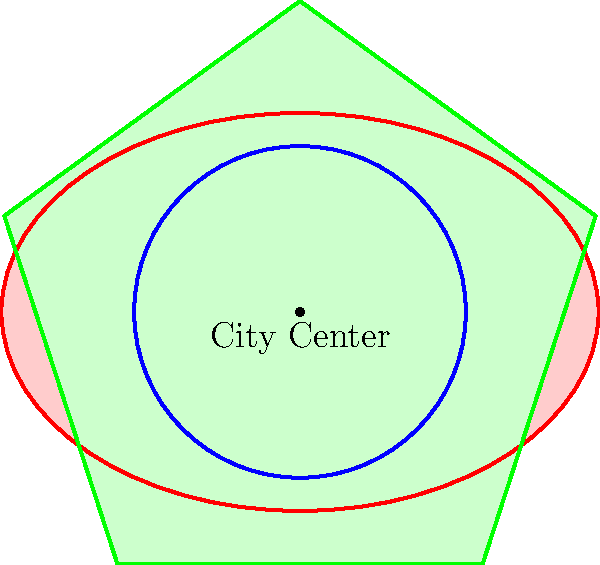Based on the map showing the changing boundaries of Manchester throughout history, which period saw the most significant expansion of the city's borders, and what historical event might have contributed to this growth? To answer this question, let's analyze the map step-by-step:

1. The map shows three distinct periods in Manchester's history, represented by different shapes and colors:
   - Blue circle: Medieval Manchester
   - Red ellipse: Industrial Revolution Manchester
   - Green pentagon: Modern Greater Manchester

2. Comparing the sizes of these shapes:
   - The blue circle (Medieval Manchester) is the smallest.
   - The red ellipse (Industrial Revolution Manchester) is noticeably larger than the medieval boundaries.
   - The green pentagon (Modern Greater Manchester) is significantly larger than both previous periods.

3. The most significant expansion is clearly between the Industrial Revolution period and the Modern Greater Manchester period.

4. Historical context:
   - The Industrial Revolution (late 18th to 19th century) brought rapid growth to Manchester due to textile manufacturing and other industries.
   - However, the even larger expansion to Modern Greater Manchester likely occurred in the 20th century.

5. A key historical event that contributed to this growth was the Local Government Act of 1972, which created the Metropolitan County of Greater Manchester in 1974. This act reorganized local government boundaries, incorporating surrounding towns and boroughs into a larger administrative area.

Therefore, the most significant expansion of Manchester's borders occurred in the modern period, likely due to the creation of Greater Manchester in 1974.
Answer: Modern period; creation of Greater Manchester (1974) 